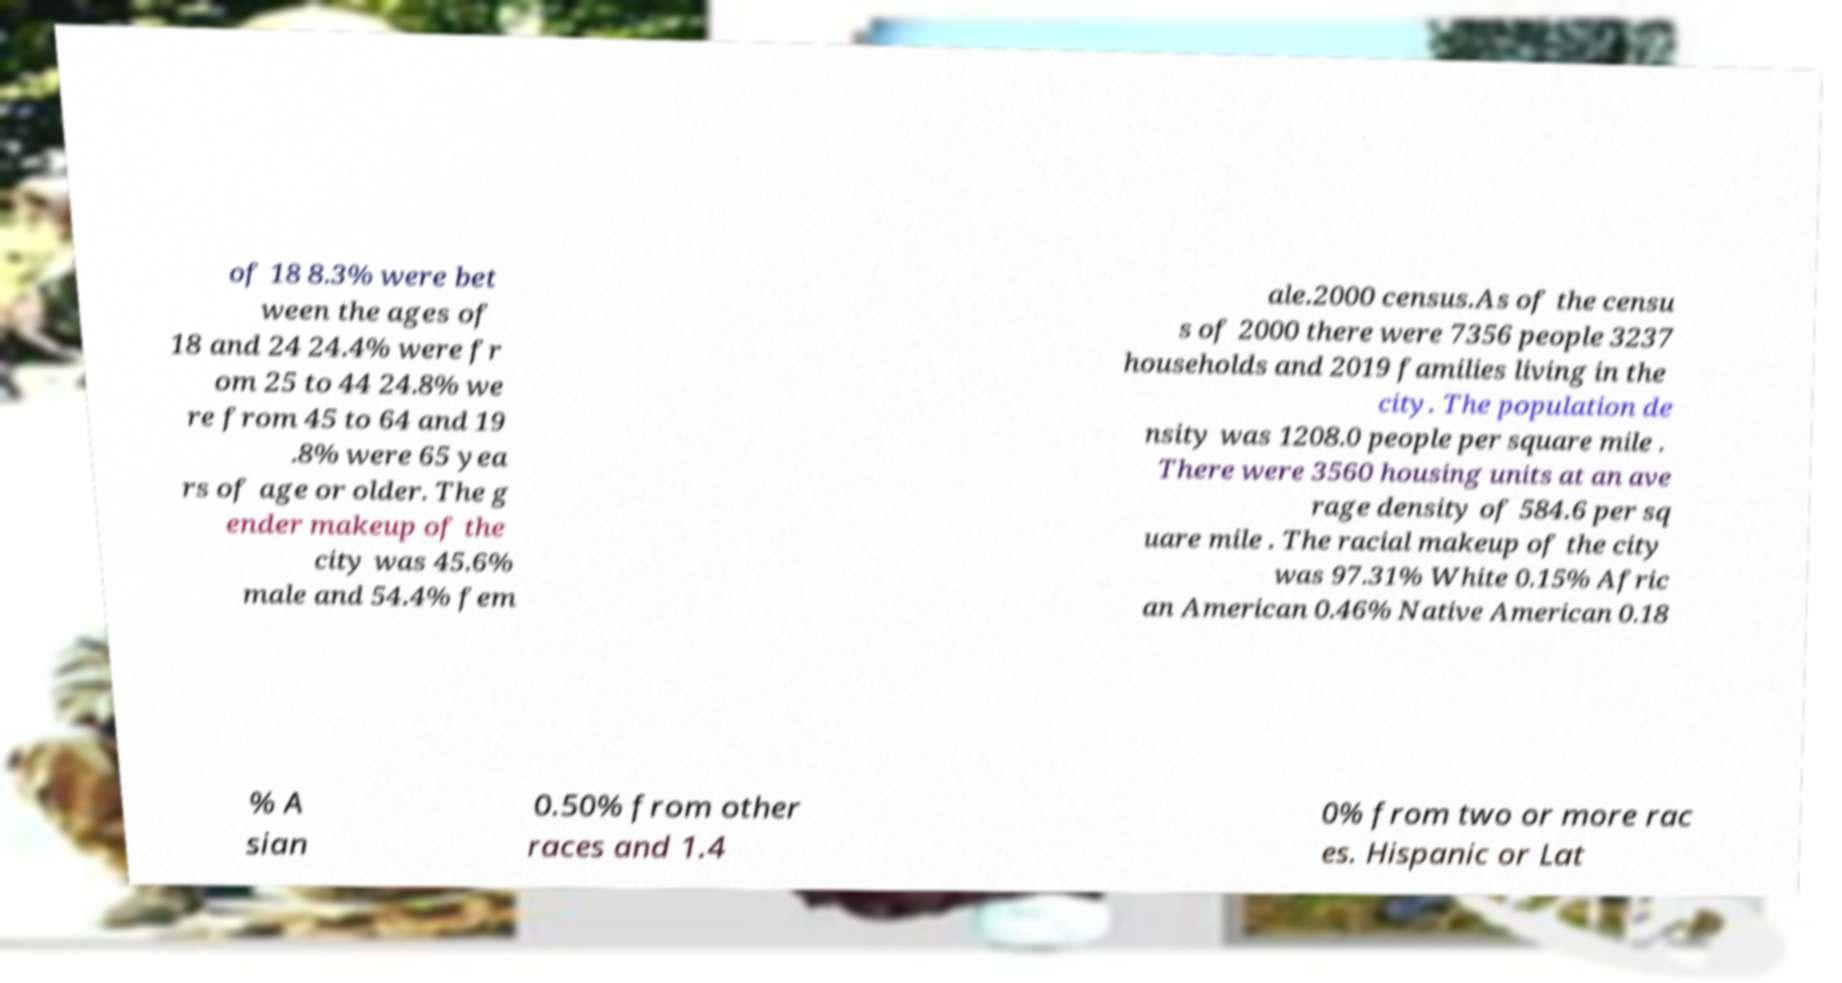Could you assist in decoding the text presented in this image and type it out clearly? of 18 8.3% were bet ween the ages of 18 and 24 24.4% were fr om 25 to 44 24.8% we re from 45 to 64 and 19 .8% were 65 yea rs of age or older. The g ender makeup of the city was 45.6% male and 54.4% fem ale.2000 census.As of the censu s of 2000 there were 7356 people 3237 households and 2019 families living in the city. The population de nsity was 1208.0 people per square mile . There were 3560 housing units at an ave rage density of 584.6 per sq uare mile . The racial makeup of the city was 97.31% White 0.15% Afric an American 0.46% Native American 0.18 % A sian 0.50% from other races and 1.4 0% from two or more rac es. Hispanic or Lat 